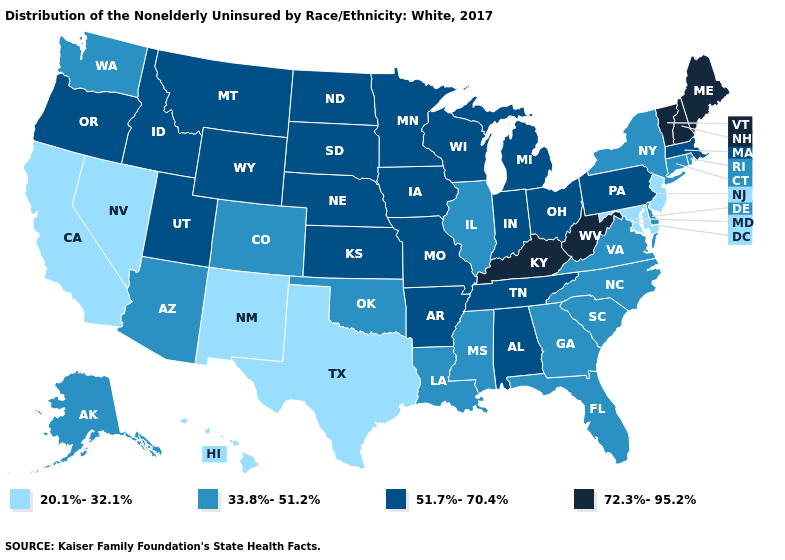Which states have the highest value in the USA?
Keep it brief. Kentucky, Maine, New Hampshire, Vermont, West Virginia. Does Delaware have the same value as South Carolina?
Give a very brief answer. Yes. What is the value of Hawaii?
Be succinct. 20.1%-32.1%. What is the highest value in the USA?
Give a very brief answer. 72.3%-95.2%. Does North Carolina have the lowest value in the USA?
Give a very brief answer. No. What is the value of South Carolina?
Write a very short answer. 33.8%-51.2%. What is the value of Maryland?
Give a very brief answer. 20.1%-32.1%. Among the states that border Alabama , does Tennessee have the highest value?
Short answer required. Yes. Name the states that have a value in the range 72.3%-95.2%?
Write a very short answer. Kentucky, Maine, New Hampshire, Vermont, West Virginia. What is the value of Alabama?
Give a very brief answer. 51.7%-70.4%. Name the states that have a value in the range 72.3%-95.2%?
Give a very brief answer. Kentucky, Maine, New Hampshire, Vermont, West Virginia. Name the states that have a value in the range 51.7%-70.4%?
Give a very brief answer. Alabama, Arkansas, Idaho, Indiana, Iowa, Kansas, Massachusetts, Michigan, Minnesota, Missouri, Montana, Nebraska, North Dakota, Ohio, Oregon, Pennsylvania, South Dakota, Tennessee, Utah, Wisconsin, Wyoming. Name the states that have a value in the range 72.3%-95.2%?
Keep it brief. Kentucky, Maine, New Hampshire, Vermont, West Virginia. What is the lowest value in the USA?
Keep it brief. 20.1%-32.1%. Does the first symbol in the legend represent the smallest category?
Write a very short answer. Yes. 